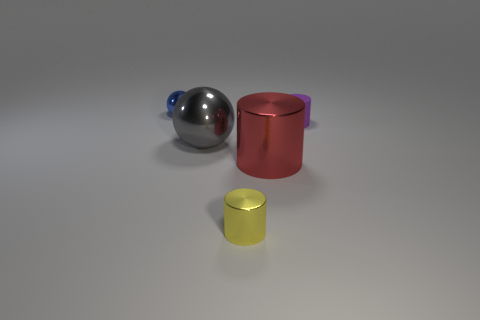There is a yellow metal cylinder; does it have the same size as the metal cylinder that is to the right of the small metallic cylinder?
Your response must be concise. No. The small metallic object that is behind the red shiny cylinder has what shape?
Your answer should be very brief. Sphere. There is a small metallic object that is in front of the shiny sphere behind the large gray metal thing; are there any shiny objects in front of it?
Offer a terse response. No. There is a large object that is the same shape as the small blue metal thing; what is it made of?
Ensure brevity in your answer.  Metal. Are there any other things that have the same material as the large gray thing?
Give a very brief answer. Yes. How many cylinders are either big red metal things or tiny yellow objects?
Keep it short and to the point. 2. There is a object that is behind the purple rubber thing; is it the same size as the thing that is in front of the large red cylinder?
Make the answer very short. Yes. What material is the sphere in front of the object that is behind the purple matte cylinder made of?
Offer a very short reply. Metal. Are there fewer metal things that are right of the gray shiny thing than large red shiny objects?
Keep it short and to the point. No. There is a blue thing that is made of the same material as the red object; what shape is it?
Your answer should be very brief. Sphere. 